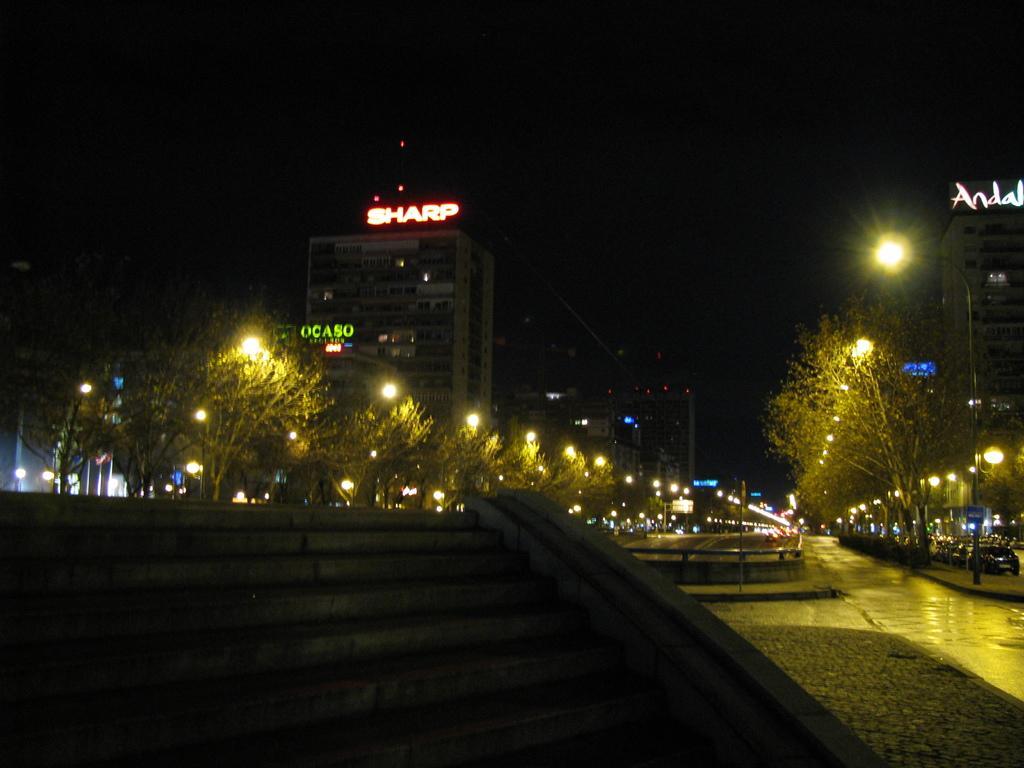Describe this image in one or two sentences. In this image we can see steps, road, light poles, vehicles, trees, buildings, name boards on the buildings and other objects. In the background the image is dark. 